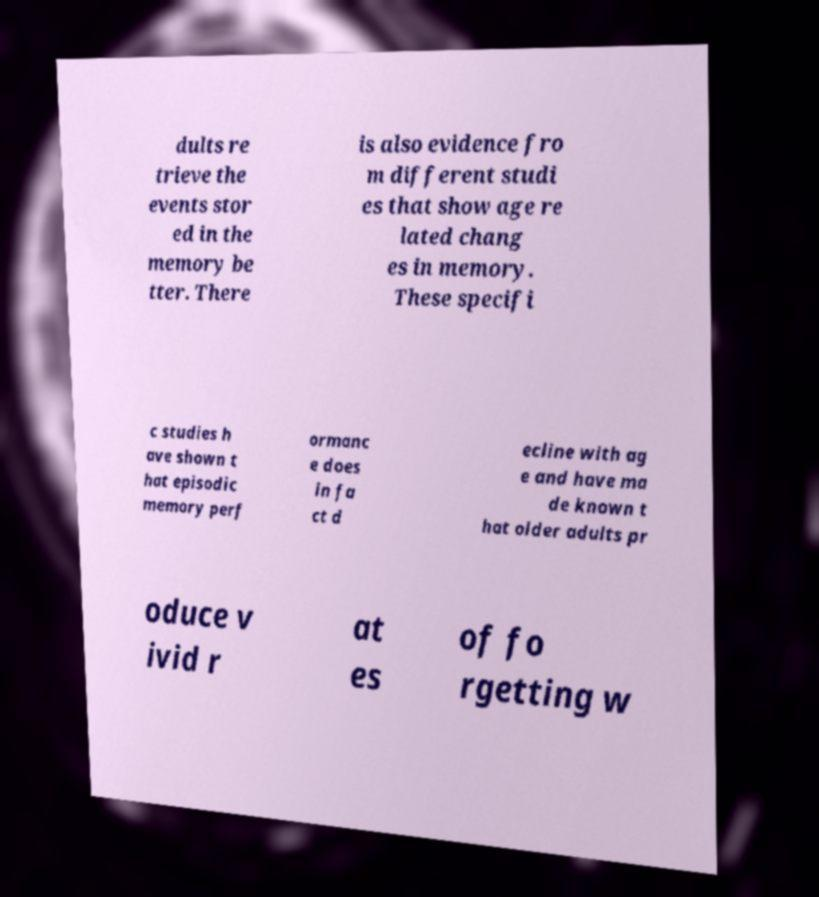Please identify and transcribe the text found in this image. dults re trieve the events stor ed in the memory be tter. There is also evidence fro m different studi es that show age re lated chang es in memory. These specifi c studies h ave shown t hat episodic memory perf ormanc e does in fa ct d ecline with ag e and have ma de known t hat older adults pr oduce v ivid r at es of fo rgetting w 